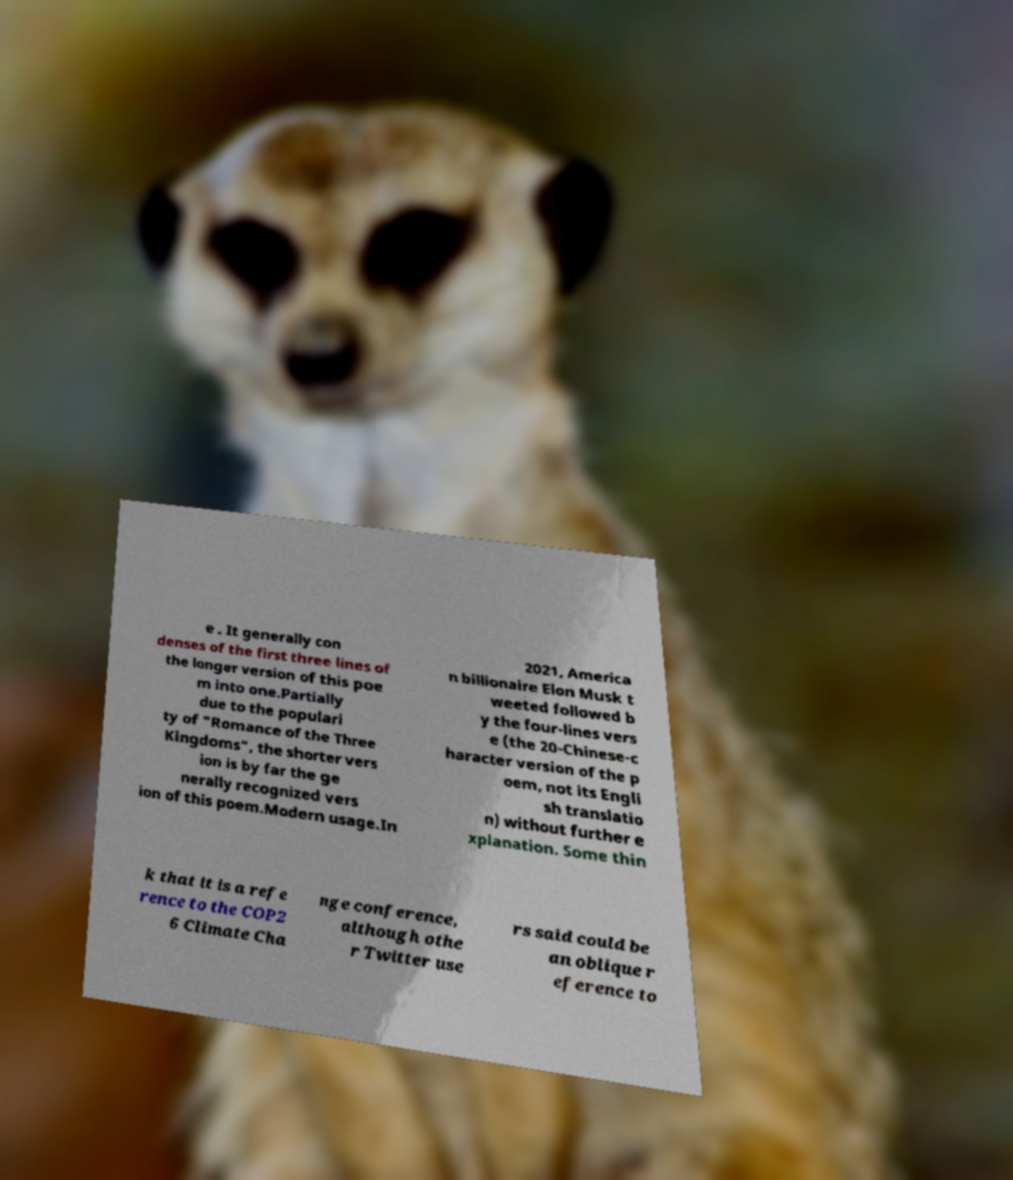For documentation purposes, I need the text within this image transcribed. Could you provide that? e . It generally con denses of the first three lines of the longer version of this poe m into one.Partially due to the populari ty of "Romance of the Three Kingdoms", the shorter vers ion is by far the ge nerally recognized vers ion of this poem.Modern usage.In 2021, America n billionaire Elon Musk t weeted followed b y the four-lines vers e (the 20-Chinese-c haracter version of the p oem, not its Engli sh translatio n) without further e xplanation. Some thin k that it is a refe rence to the COP2 6 Climate Cha nge conference, although othe r Twitter use rs said could be an oblique r eference to 